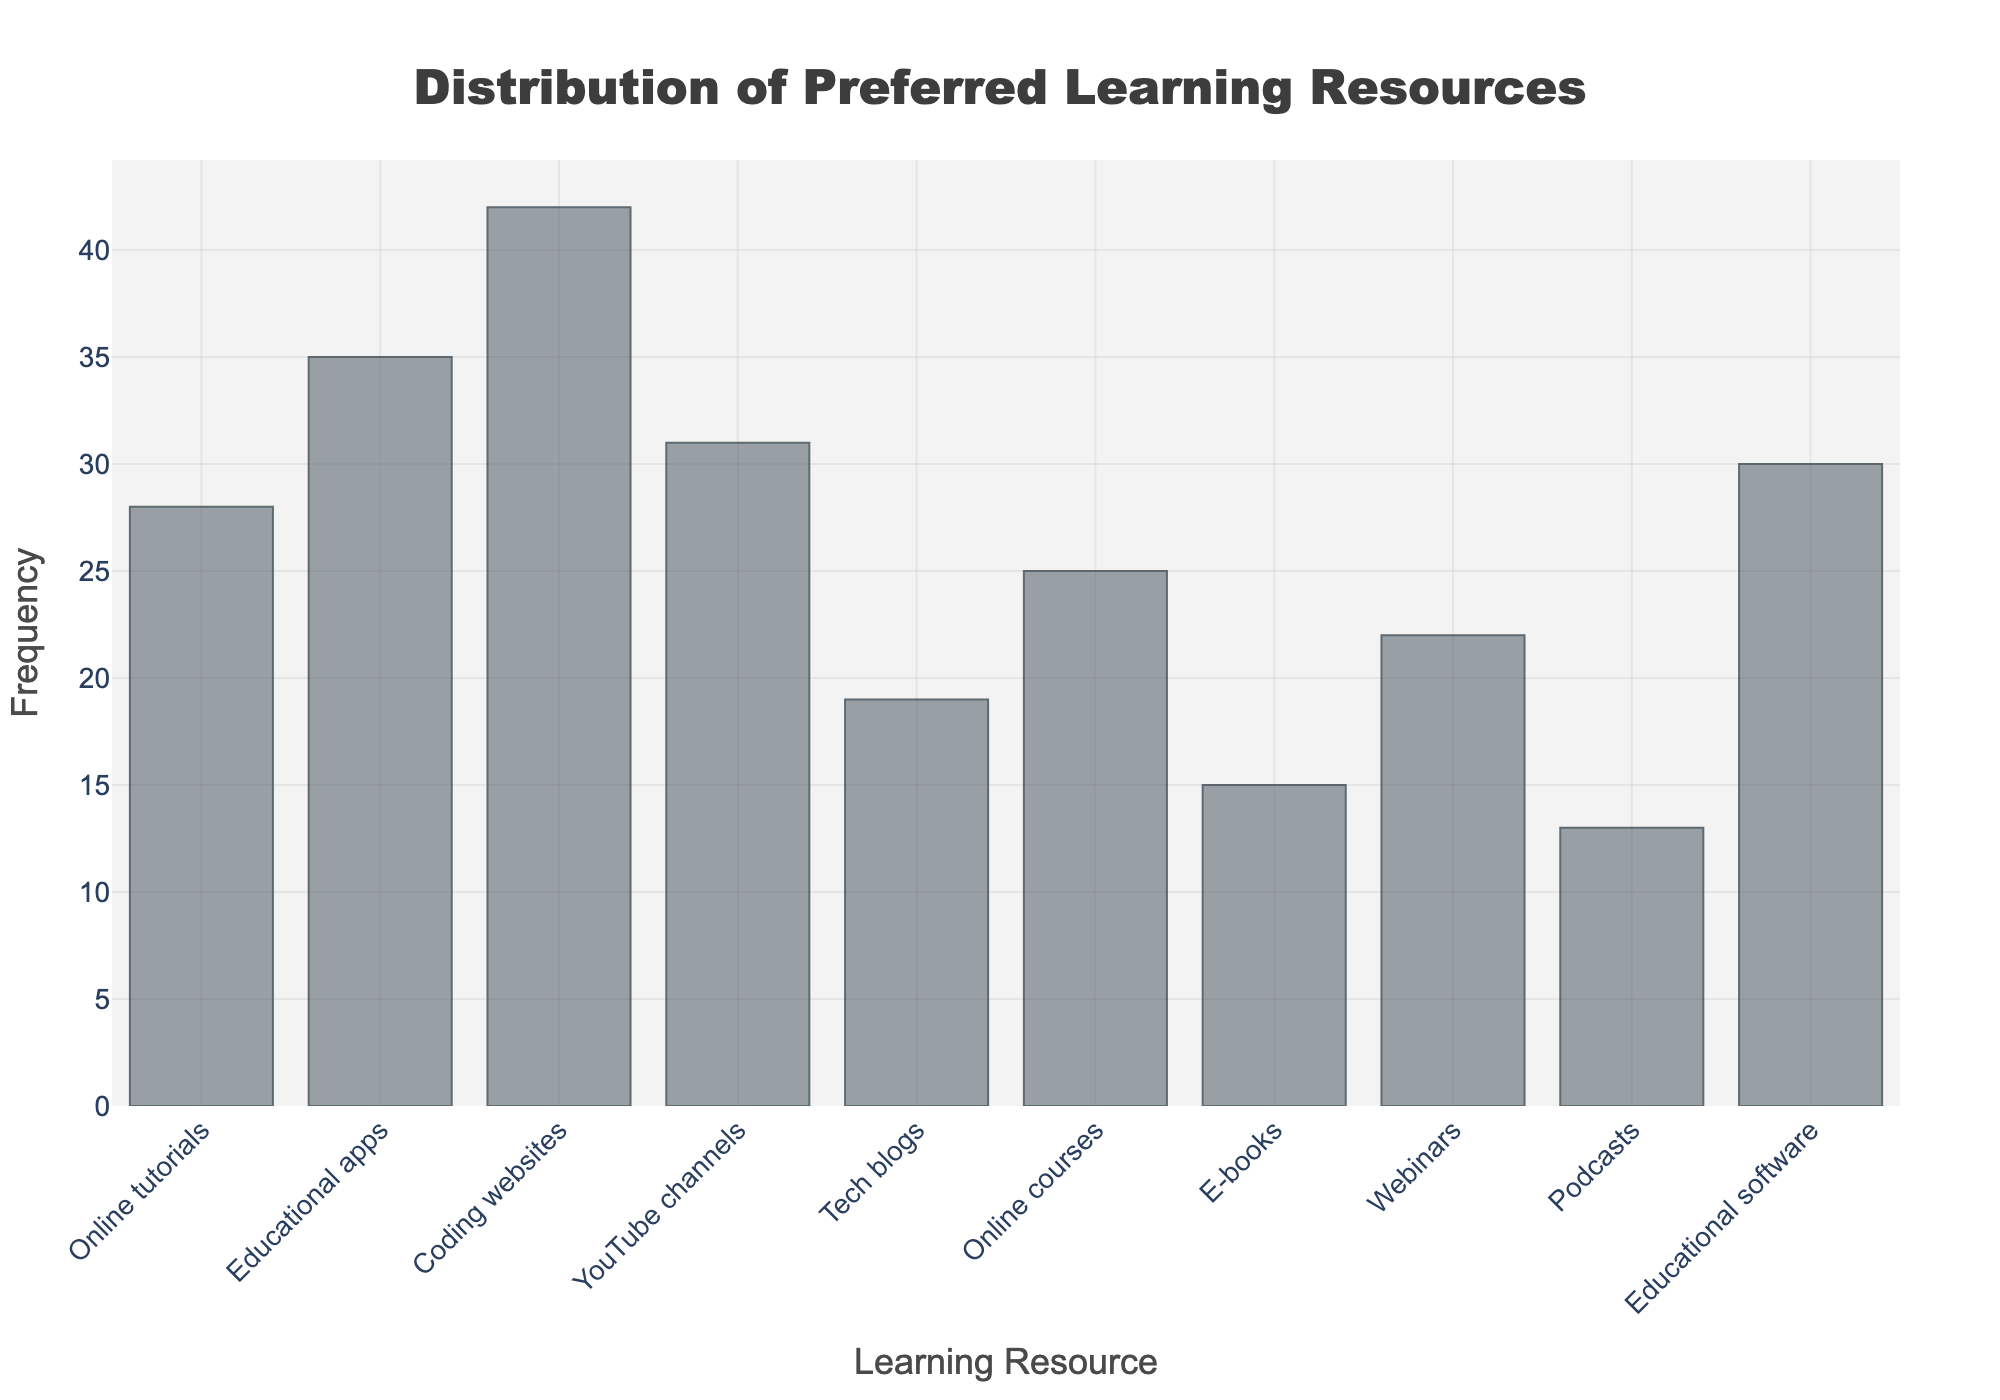What is the most preferred learning resource among parents? The bar representing "Coding websites" has the highest frequency value on the y-axis.
Answer: Coding websites How many parents prefer educational apps as a learning resource? The bar for "Educational apps" reaches the 35 mark on the y-axis.
Answer: 35 Which learning resource is the least preferred among parents? The bar representing "Podcasts" has the lowest frequency on the y-axis.
Answer: Podcasts Is there a higher preference for YouTube channels or webinars among parents? Comparing the heights of the bars, the "YouTube channels" bar reaches 31 and the "Webinars" bar reaches 22.
Answer: YouTube channels What is the combined frequency of parents who prefer online courses and e-books? Add the frequency values of "Online courses" (25) and "E-books" (15). So, 25 + 15 = 40.
Answer: 40 Compare the frequency of parents preferring educational software to those preferring online tutorials. Which one is higher? The bar for "Educational software" reaches 30, while the bar for "Online tutorials" reaches 28.
Answer: Educational software Which two learning resources have a combined frequency equal to that of coding websites? The "Coding websites" bar has a frequency of 42. Adding "Educational software" (30) and "E-books" (15) equals 45, which exceeds 42. Adding "Educational apps" (35) and "Podcasts" (13) equals 48, which also exceeds 42. However, the combination of "Online courses" (25) and "Webinars" (22) equals 47, which is the closest combination but still exceeds 42. Therefore, try "YouTube channels" (31) and "Online tutorials" (28). These summed give 59 which is also not correct. Let's take another combination, "Webinars" (22) and "Podcasts" (13), which equals 35. Finally, checking "Educational apps" and "Online courses" which sum up to 35 + 25, getting 60 exceeding 42.
Answer: No exact combination of two What is the average frequency of all learning resources? Sum all frequency values: 28 + 35 + 42 + 31 + 19 + 25 + 15 + 22 + 13 + 30 = 260. There are 10 resources, so the average is 260 / 10 = 26.
Answer: 26 Which learning resource has a frequency closest to the average frequency of 26? By scanning each bar, "Online courses" with a frequency of 25 is the closest to 26.
Answer: Online courses 